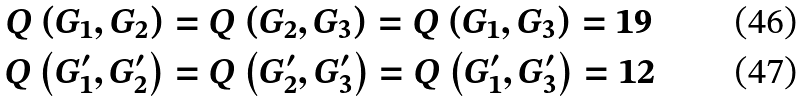Convert formula to latex. <formula><loc_0><loc_0><loc_500><loc_500>Q \left ( G _ { 1 } , G _ { 2 } \right ) & = Q \left ( G _ { 2 } , G _ { 3 } \right ) = Q \left ( G _ { 1 } , G _ { 3 } \right ) = 1 9 \\ Q \left ( G _ { 1 } ^ { \prime } , G _ { 2 } ^ { \prime } \right ) & = Q \left ( G _ { 2 } ^ { \prime } , G _ { 3 } ^ { \prime } \right ) = Q \left ( G _ { 1 } ^ { \prime } , G _ { 3 } ^ { \prime } \right ) = 1 2</formula> 